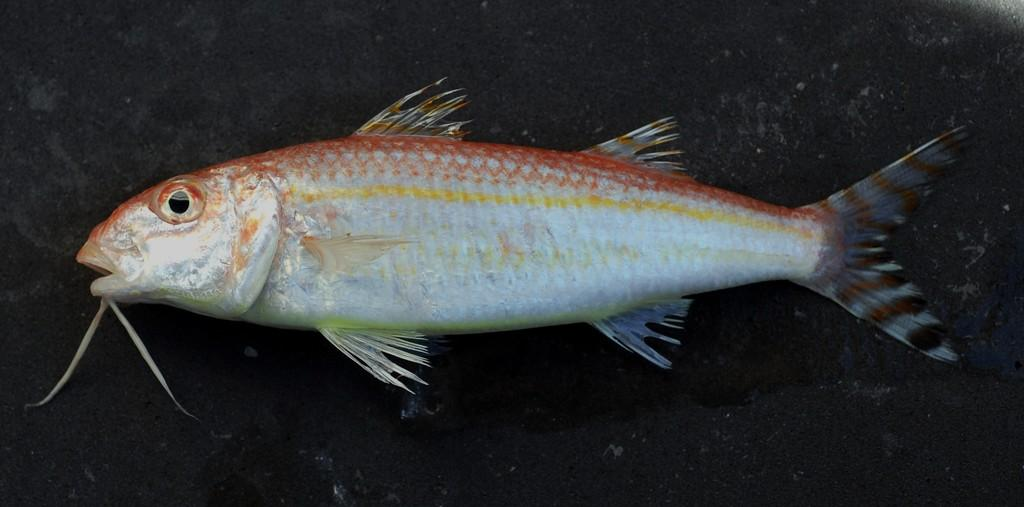What type of animal is in the image? There is a fish in the image. What color is the background of the image? The background of the image is black. How many mice are visible in the image? There are no mice present in the image. What type of glue is being used by the fish in the image? There is no glue or any indication of glue usage in the image. 